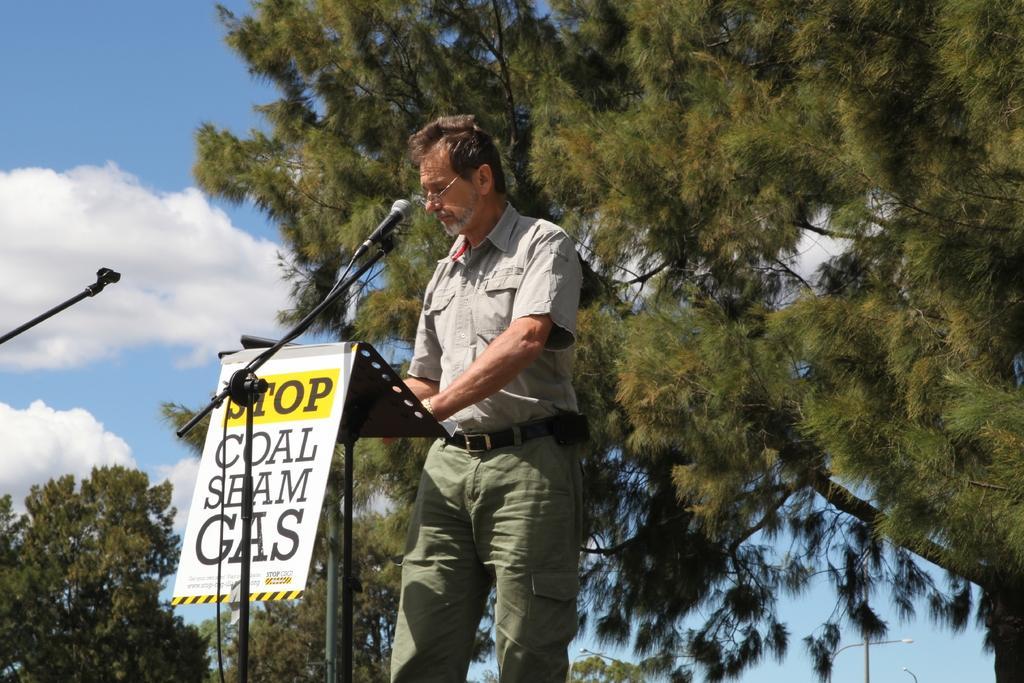Could you give a brief overview of what you see in this image? In this picture, we can see a person resting his hands on the object, we can see poster with some text in it, we can microphones, trees, lights, poles, and the sky with clouds. 